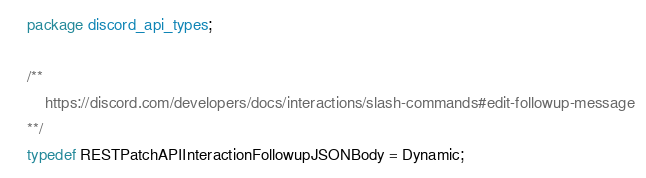<code> <loc_0><loc_0><loc_500><loc_500><_Haxe_>package discord_api_types;

/**
	https://discord.com/developers/docs/interactions/slash-commands#edit-followup-message
**/
typedef RESTPatchAPIInteractionFollowupJSONBody = Dynamic;</code> 